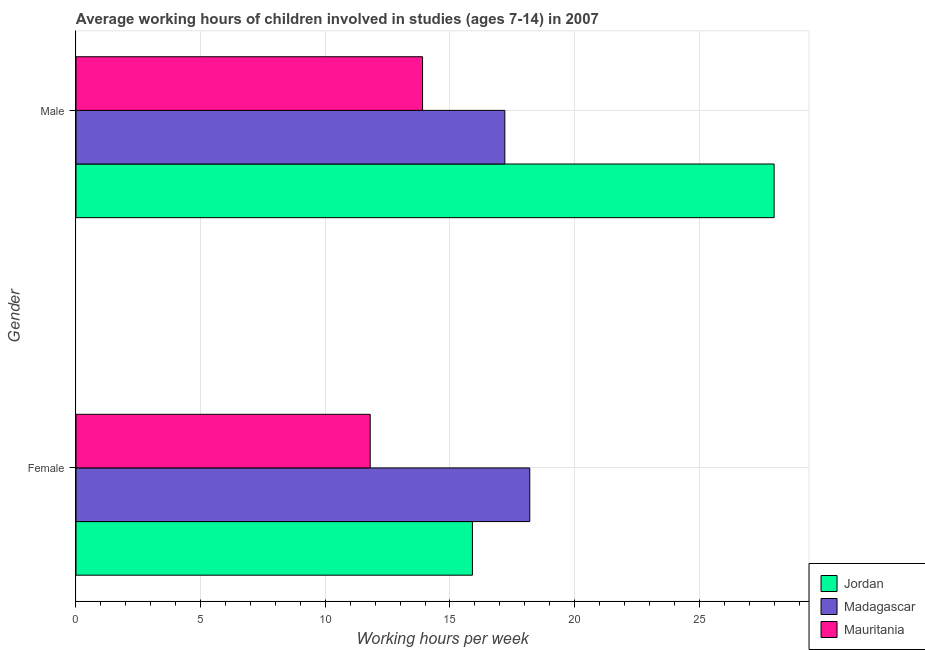How many different coloured bars are there?
Provide a short and direct response. 3. Are the number of bars on each tick of the Y-axis equal?
Offer a terse response. Yes. How many bars are there on the 1st tick from the top?
Your answer should be very brief. 3. How many bars are there on the 1st tick from the bottom?
Make the answer very short. 3. What is the label of the 2nd group of bars from the top?
Keep it short and to the point. Female. What is the average working hour of male children in Mauritania?
Your response must be concise. 13.9. Across all countries, what is the maximum average working hour of male children?
Provide a succinct answer. 28. Across all countries, what is the minimum average working hour of male children?
Offer a terse response. 13.9. In which country was the average working hour of male children maximum?
Your response must be concise. Jordan. In which country was the average working hour of male children minimum?
Provide a succinct answer. Mauritania. What is the total average working hour of male children in the graph?
Offer a terse response. 59.1. What is the difference between the average working hour of male children in Mauritania and that in Jordan?
Provide a short and direct response. -14.1. What is the average average working hour of female children per country?
Keep it short and to the point. 15.3. In how many countries, is the average working hour of female children greater than 10 hours?
Give a very brief answer. 3. What is the ratio of the average working hour of female children in Mauritania to that in Jordan?
Keep it short and to the point. 0.74. Is the average working hour of male children in Jordan less than that in Mauritania?
Your answer should be compact. No. What does the 1st bar from the top in Female represents?
Keep it short and to the point. Mauritania. What does the 3rd bar from the bottom in Male represents?
Give a very brief answer. Mauritania. How many bars are there?
Provide a succinct answer. 6. How many countries are there in the graph?
Keep it short and to the point. 3. How many legend labels are there?
Keep it short and to the point. 3. How are the legend labels stacked?
Offer a very short reply. Vertical. What is the title of the graph?
Your answer should be compact. Average working hours of children involved in studies (ages 7-14) in 2007. What is the label or title of the X-axis?
Provide a short and direct response. Working hours per week. What is the label or title of the Y-axis?
Provide a short and direct response. Gender. What is the Working hours per week of Jordan in Female?
Your response must be concise. 15.9. What is the Working hours per week in Mauritania in Female?
Give a very brief answer. 11.8. What is the Working hours per week of Jordan in Male?
Provide a succinct answer. 28. Across all Gender, what is the maximum Working hours per week in Jordan?
Your answer should be very brief. 28. Across all Gender, what is the minimum Working hours per week in Madagascar?
Provide a short and direct response. 17.2. What is the total Working hours per week in Jordan in the graph?
Make the answer very short. 43.9. What is the total Working hours per week of Madagascar in the graph?
Your response must be concise. 35.4. What is the total Working hours per week of Mauritania in the graph?
Give a very brief answer. 25.7. What is the difference between the Working hours per week in Madagascar in Female and that in Male?
Your response must be concise. 1. What is the difference between the Working hours per week of Mauritania in Female and that in Male?
Offer a very short reply. -2.1. What is the difference between the Working hours per week of Jordan in Female and the Working hours per week of Madagascar in Male?
Offer a very short reply. -1.3. What is the difference between the Working hours per week in Jordan in Female and the Working hours per week in Mauritania in Male?
Keep it short and to the point. 2. What is the difference between the Working hours per week in Madagascar in Female and the Working hours per week in Mauritania in Male?
Your response must be concise. 4.3. What is the average Working hours per week in Jordan per Gender?
Your answer should be very brief. 21.95. What is the average Working hours per week in Madagascar per Gender?
Make the answer very short. 17.7. What is the average Working hours per week of Mauritania per Gender?
Keep it short and to the point. 12.85. What is the difference between the Working hours per week of Jordan and Working hours per week of Madagascar in Female?
Make the answer very short. -2.3. What is the difference between the Working hours per week of Jordan and Working hours per week of Mauritania in Female?
Your answer should be compact. 4.1. What is the difference between the Working hours per week in Madagascar and Working hours per week in Mauritania in Female?
Offer a very short reply. 6.4. What is the difference between the Working hours per week of Jordan and Working hours per week of Madagascar in Male?
Ensure brevity in your answer.  10.8. What is the difference between the Working hours per week of Madagascar and Working hours per week of Mauritania in Male?
Your answer should be very brief. 3.3. What is the ratio of the Working hours per week in Jordan in Female to that in Male?
Keep it short and to the point. 0.57. What is the ratio of the Working hours per week of Madagascar in Female to that in Male?
Keep it short and to the point. 1.06. What is the ratio of the Working hours per week of Mauritania in Female to that in Male?
Make the answer very short. 0.85. What is the difference between the highest and the lowest Working hours per week in Jordan?
Ensure brevity in your answer.  12.1. What is the difference between the highest and the lowest Working hours per week in Madagascar?
Make the answer very short. 1. What is the difference between the highest and the lowest Working hours per week in Mauritania?
Your answer should be very brief. 2.1. 